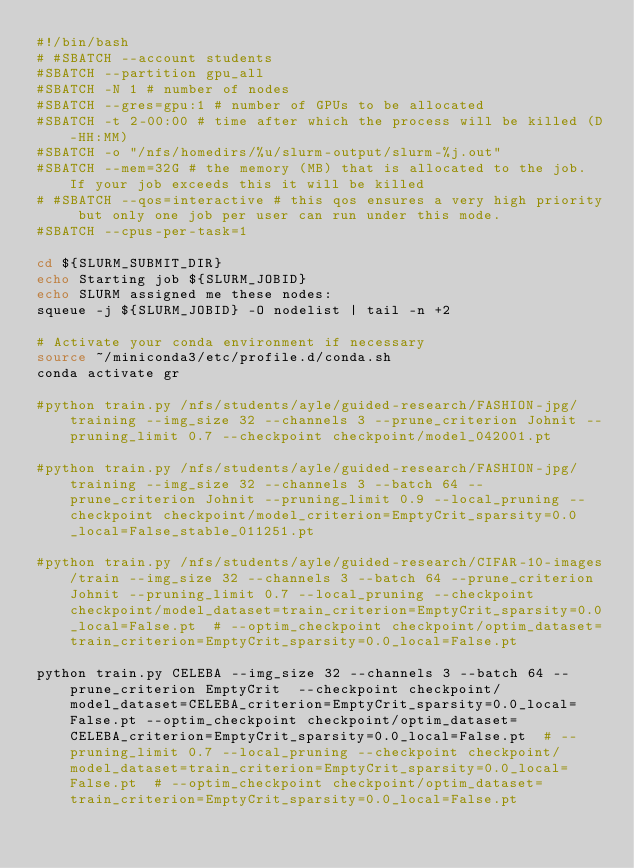<code> <loc_0><loc_0><loc_500><loc_500><_Bash_>#!/bin/bash
# #SBATCH --account students
#SBATCH --partition gpu_all
#SBATCH -N 1 # number of nodes
#SBATCH --gres=gpu:1 # number of GPUs to be allocated
#SBATCH -t 2-00:00 # time after which the process will be killed (D-HH:MM)
#SBATCH -o "/nfs/homedirs/%u/slurm-output/slurm-%j.out"
#SBATCH --mem=32G # the memory (MB) that is allocated to the job. If your job exceeds this it will be killed
# #SBATCH --qos=interactive # this qos ensures a very high priority but only one job per user can run under this mode.
#SBATCH --cpus-per-task=1

cd ${SLURM_SUBMIT_DIR}
echo Starting job ${SLURM_JOBID}
echo SLURM assigned me these nodes:
squeue -j ${SLURM_JOBID} -O nodelist | tail -n +2

# Activate your conda environment if necessary
source ~/miniconda3/etc/profile.d/conda.sh
conda activate gr

#python train.py /nfs/students/ayle/guided-research/FASHION-jpg/training --img_size 32 --channels 3 --prune_criterion Johnit --pruning_limit 0.7 --checkpoint checkpoint/model_042001.pt

#python train.py /nfs/students/ayle/guided-research/FASHION-jpg/training --img_size 32 --channels 3 --batch 64 --prune_criterion Johnit --pruning_limit 0.9 --local_pruning --checkpoint checkpoint/model_criterion=EmptyCrit_sparsity=0.0_local=False_stable_011251.pt

#python train.py /nfs/students/ayle/guided-research/CIFAR-10-images/train --img_size 32 --channels 3 --batch 64 --prune_criterion Johnit --pruning_limit 0.7 --local_pruning --checkpoint checkpoint/model_dataset=train_criterion=EmptyCrit_sparsity=0.0_local=False.pt  # --optim_checkpoint checkpoint/optim_dataset=train_criterion=EmptyCrit_sparsity=0.0_local=False.pt

python train.py CELEBA --img_size 32 --channels 3 --batch 64 --prune_criterion EmptyCrit  --checkpoint checkpoint/model_dataset=CELEBA_criterion=EmptyCrit_sparsity=0.0_local=False.pt --optim_checkpoint checkpoint/optim_dataset=CELEBA_criterion=EmptyCrit_sparsity=0.0_local=False.pt  # --pruning_limit 0.7 --local_pruning --checkpoint checkpoint/model_dataset=train_criterion=EmptyCrit_sparsity=0.0_local=False.pt  # --optim_checkpoint checkpoint/optim_dataset=train_criterion=EmptyCrit_sparsity=0.0_local=False.pt</code> 